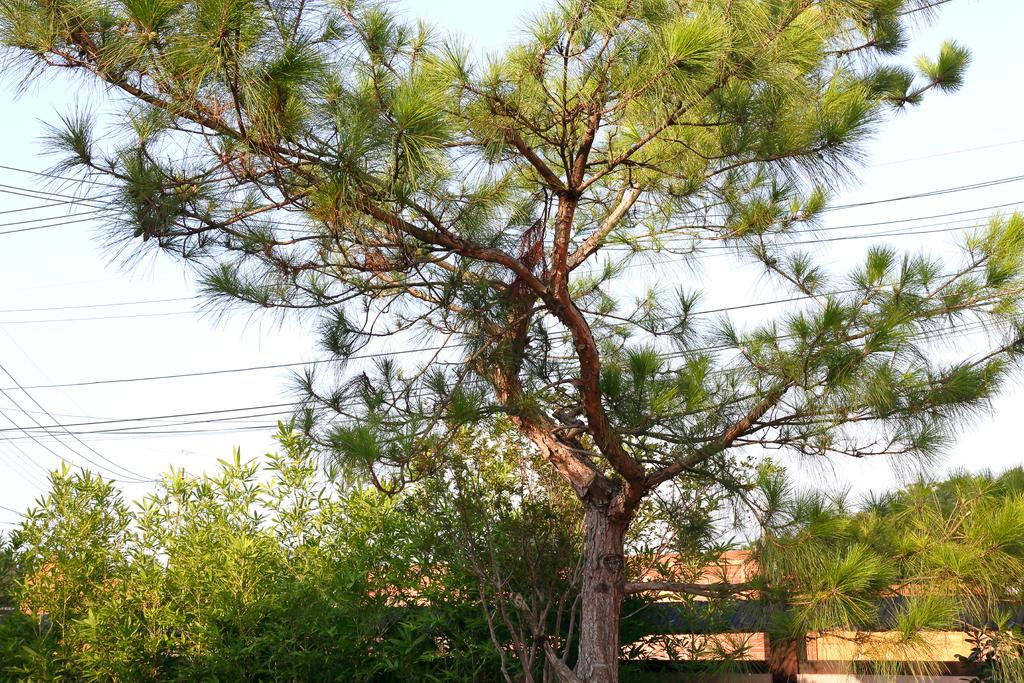What is the main subject in the center of the image? There is a tree in the center of the image. What other objects can be seen in the image? There is a fence, a group of plants, and wires visible in the image. What is the condition of the sky in the image? The sky is visible in the image and appears cloudy. How does the wind affect the yarn in the image? There is no yarn present in the image, so the wind's effect cannot be determined. 